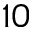Convert formula to latex. <formula><loc_0><loc_0><loc_500><loc_500>1 0</formula> 